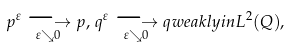<formula> <loc_0><loc_0><loc_500><loc_500>p ^ { \varepsilon } \underset { \varepsilon \searrow 0 } { \longrightarrow } p , \, q ^ { \varepsilon } \underset { \varepsilon \searrow 0 } { \longrightarrow } q w e a k l y i n L ^ { 2 } ( Q ) ,</formula> 